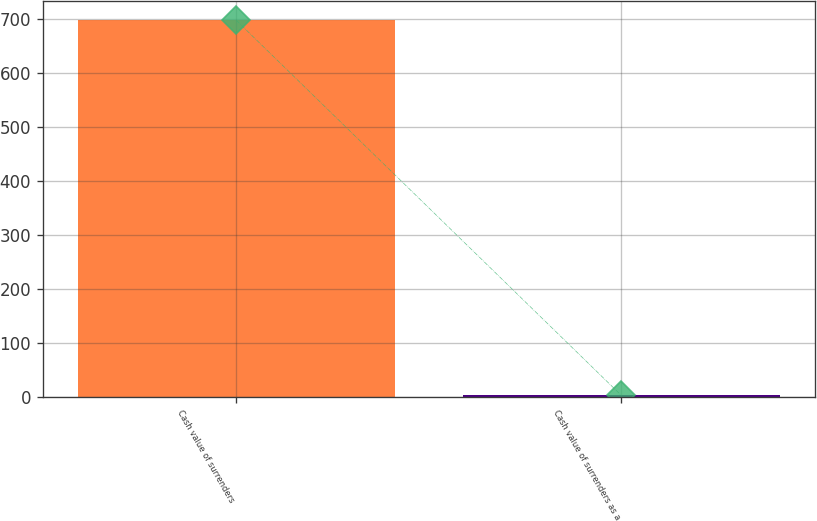<chart> <loc_0><loc_0><loc_500><loc_500><bar_chart><fcel>Cash value of surrenders<fcel>Cash value of surrenders as a<nl><fcel>698<fcel>3.5<nl></chart> 